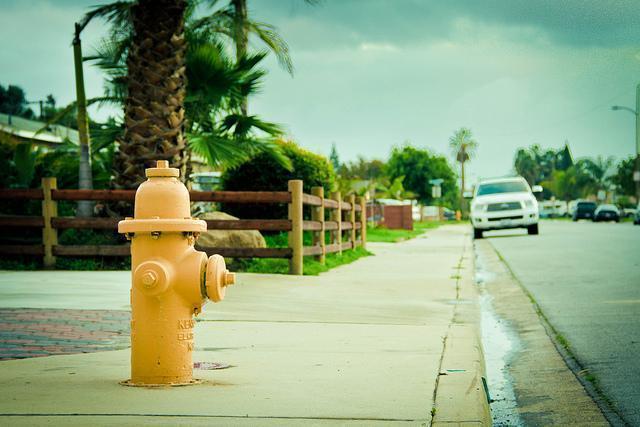What kind of weather is one likely to experience in this area?
Select the accurate answer and provide explanation: 'Answer: answer
Rationale: rationale.'
Options: Tropical, arid, rainy, cold. Answer: tropical.
Rationale: The weather is tropical. 